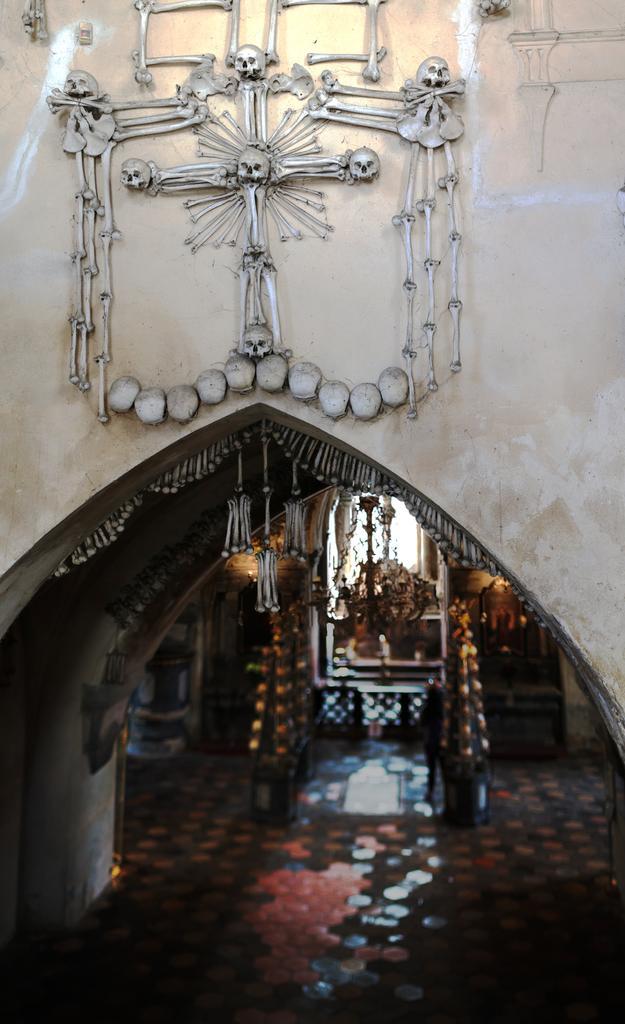Describe this image in one or two sentences. In this image, this looks like a design with the skeleton on the building wall. Here is an arch. I can see few objects inside. 